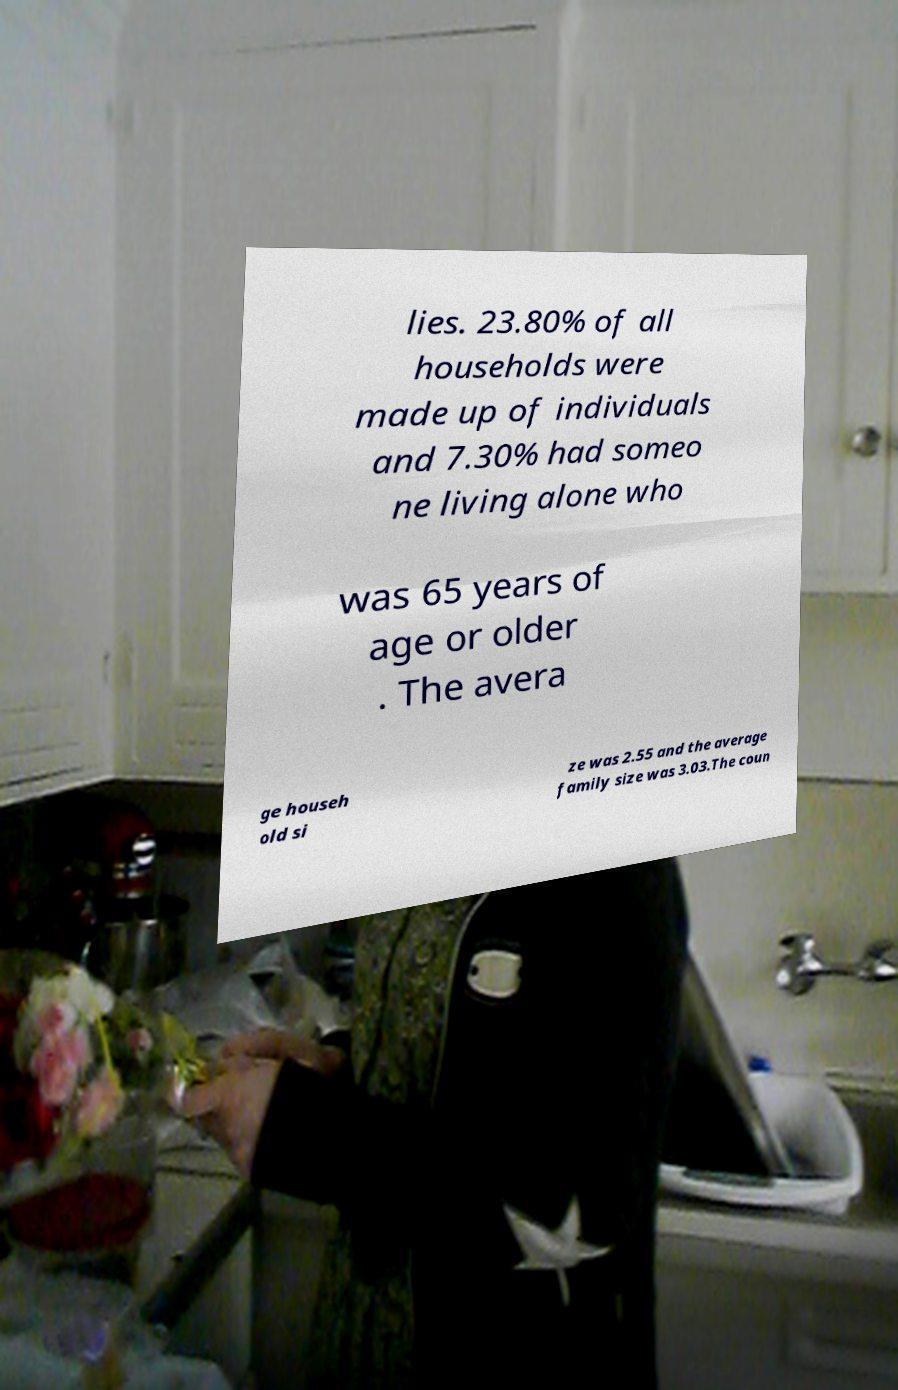What messages or text are displayed in this image? I need them in a readable, typed format. lies. 23.80% of all households were made up of individuals and 7.30% had someo ne living alone who was 65 years of age or older . The avera ge househ old si ze was 2.55 and the average family size was 3.03.The coun 